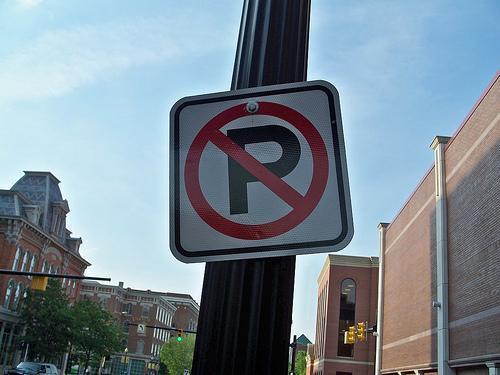How many people are pictured here?
Give a very brief answer. 0. 